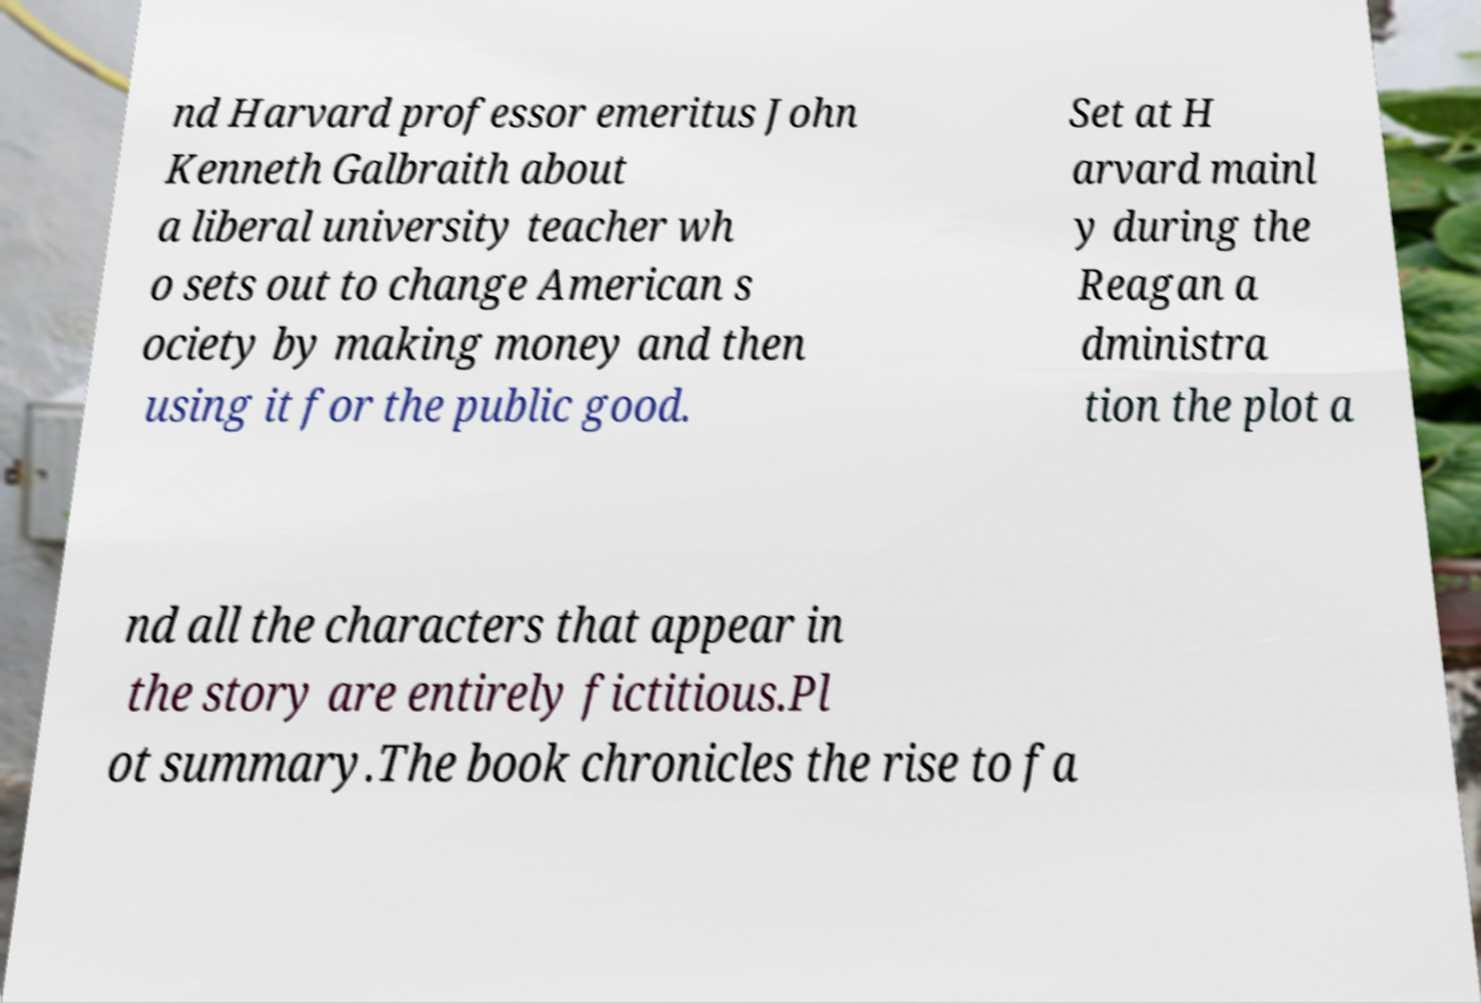There's text embedded in this image that I need extracted. Can you transcribe it verbatim? nd Harvard professor emeritus John Kenneth Galbraith about a liberal university teacher wh o sets out to change American s ociety by making money and then using it for the public good. Set at H arvard mainl y during the Reagan a dministra tion the plot a nd all the characters that appear in the story are entirely fictitious.Pl ot summary.The book chronicles the rise to fa 